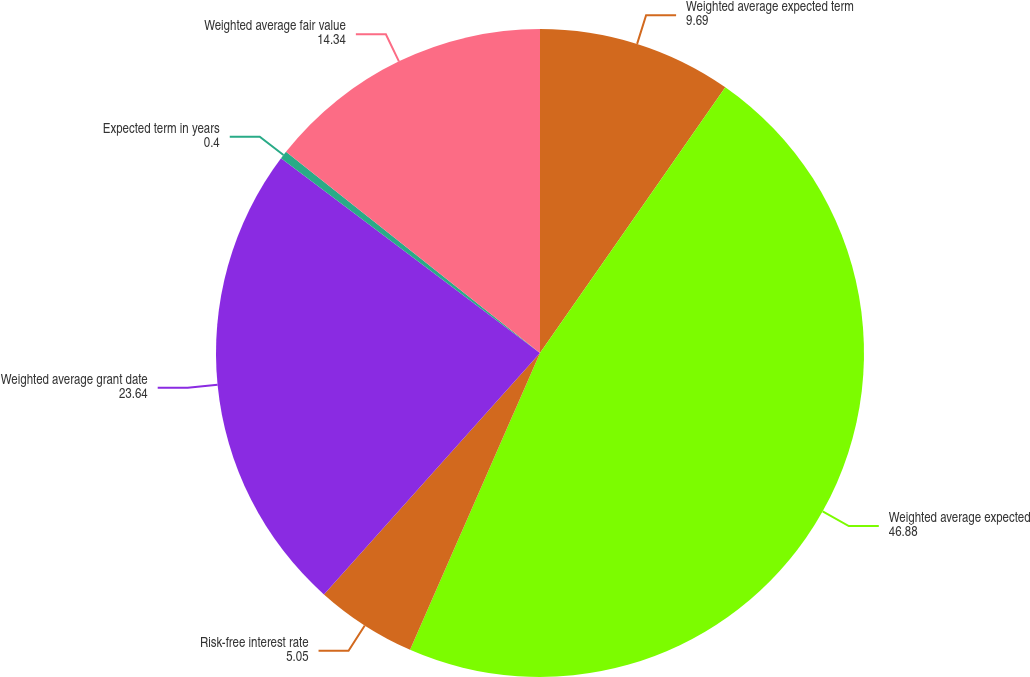Convert chart. <chart><loc_0><loc_0><loc_500><loc_500><pie_chart><fcel>Weighted average expected term<fcel>Weighted average expected<fcel>Risk-free interest rate<fcel>Weighted average grant date<fcel>Expected term in years<fcel>Weighted average fair value<nl><fcel>9.69%<fcel>46.88%<fcel>5.05%<fcel>23.64%<fcel>0.4%<fcel>14.34%<nl></chart> 